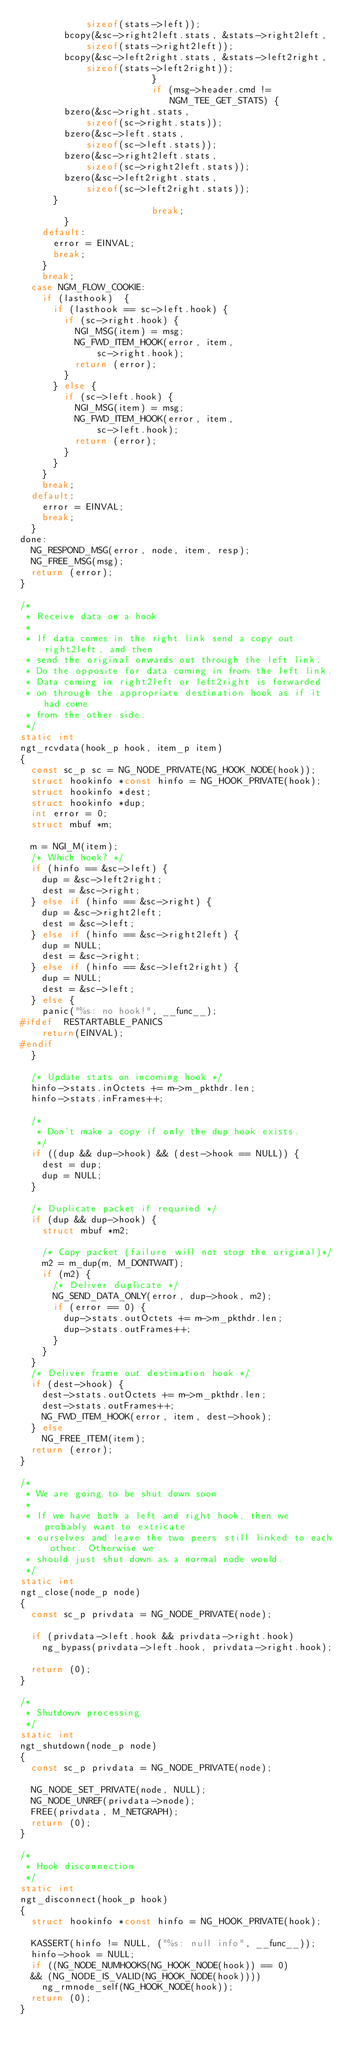Convert code to text. <code><loc_0><loc_0><loc_500><loc_500><_C_>				    sizeof(stats->left));
				bcopy(&sc->right2left.stats, &stats->right2left,
				    sizeof(stats->right2left));
				bcopy(&sc->left2right.stats, &stats->left2right,
				    sizeof(stats->left2right));
                        }
                        if (msg->header.cmd != NGM_TEE_GET_STATS) {
				bzero(&sc->right.stats,
				    sizeof(sc->right.stats));
				bzero(&sc->left.stats,
				    sizeof(sc->left.stats));
				bzero(&sc->right2left.stats,
				    sizeof(sc->right2left.stats));
				bzero(&sc->left2right.stats,
				    sizeof(sc->left2right.stats));
			}
                        break;
		    }
		default:
			error = EINVAL;
			break;
		}
		break;
	case NGM_FLOW_COOKIE:
		if (lasthook)  {
			if (lasthook == sc->left.hook) {
				if (sc->right.hook) {
					NGI_MSG(item) = msg;
					NG_FWD_ITEM_HOOK(error, item,
							sc->right.hook);
					return (error);
				}
			} else {
				if (sc->left.hook) {
					NGI_MSG(item) = msg;
					NG_FWD_ITEM_HOOK(error, item, 
							sc->left.hook);
					return (error);
				}
			}
		}
		break;
	default:
		error = EINVAL;
		break;
	}
done:
	NG_RESPOND_MSG(error, node, item, resp);
	NG_FREE_MSG(msg);
	return (error);
}

/*
 * Receive data on a hook
 *
 * If data comes in the right link send a copy out right2left, and then
 * send the original onwards out through the left link.
 * Do the opposite for data coming in from the left link.
 * Data coming in right2left or left2right is forwarded
 * on through the appropriate destination hook as if it had come
 * from the other side.
 */
static int
ngt_rcvdata(hook_p hook, item_p item)
{
	const sc_p sc = NG_NODE_PRIVATE(NG_HOOK_NODE(hook));
	struct hookinfo *const hinfo = NG_HOOK_PRIVATE(hook);
	struct hookinfo *dest;
	struct hookinfo *dup;
	int error = 0;
	struct mbuf *m;

	m = NGI_M(item);
	/* Which hook? */
	if (hinfo == &sc->left) {
		dup = &sc->left2right;
		dest = &sc->right;
	} else if (hinfo == &sc->right) {
		dup = &sc->right2left;
		dest = &sc->left;
	} else if (hinfo == &sc->right2left) {
		dup = NULL;
		dest = &sc->right;
	} else if (hinfo == &sc->left2right) {
		dup = NULL;
		dest = &sc->left;
	} else {
		panic("%s: no hook!", __func__);
#ifdef	RESTARTABLE_PANICS
		return(EINVAL);
#endif
	}

	/* Update stats on incoming hook */
	hinfo->stats.inOctets += m->m_pkthdr.len;
	hinfo->stats.inFrames++;

	/*
	 * Don't make a copy if only the dup hook exists.
	 */
	if ((dup && dup->hook) && (dest->hook == NULL)) {
		dest = dup;
		dup = NULL;
	}

	/* Duplicate packet if requried */
	if (dup && dup->hook) {
		struct mbuf *m2;

		/* Copy packet (failure will not stop the original)*/
		m2 = m_dup(m, M_DONTWAIT);
		if (m2) {
			/* Deliver duplicate */
			NG_SEND_DATA_ONLY(error, dup->hook, m2);
			if (error == 0) {
				dup->stats.outOctets += m->m_pkthdr.len;
				dup->stats.outFrames++;
			}
		}
	}
	/* Deliver frame out destination hook */
	if (dest->hook) {
		dest->stats.outOctets += m->m_pkthdr.len;
		dest->stats.outFrames++;
		NG_FWD_ITEM_HOOK(error, item, dest->hook);
	} else
		NG_FREE_ITEM(item);
	return (error);
}

/*
 * We are going to be shut down soon
 *
 * If we have both a left and right hook, then we probably want to extricate
 * ourselves and leave the two peers still linked to each other. Otherwise we
 * should just shut down as a normal node would.
 */
static int
ngt_close(node_p node)
{
	const sc_p privdata = NG_NODE_PRIVATE(node);

	if (privdata->left.hook && privdata->right.hook)
		ng_bypass(privdata->left.hook, privdata->right.hook);

	return (0);
}

/*
 * Shutdown processing
 */
static int
ngt_shutdown(node_p node)
{
	const sc_p privdata = NG_NODE_PRIVATE(node);

	NG_NODE_SET_PRIVATE(node, NULL);
	NG_NODE_UNREF(privdata->node);
	FREE(privdata, M_NETGRAPH);
	return (0);
}

/*
 * Hook disconnection
 */
static int
ngt_disconnect(hook_p hook)
{
	struct hookinfo *const hinfo = NG_HOOK_PRIVATE(hook);

	KASSERT(hinfo != NULL, ("%s: null info", __func__));
	hinfo->hook = NULL;
	if ((NG_NODE_NUMHOOKS(NG_HOOK_NODE(hook)) == 0)
	&& (NG_NODE_IS_VALID(NG_HOOK_NODE(hook))))
		ng_rmnode_self(NG_HOOK_NODE(hook));
	return (0);
}

</code> 